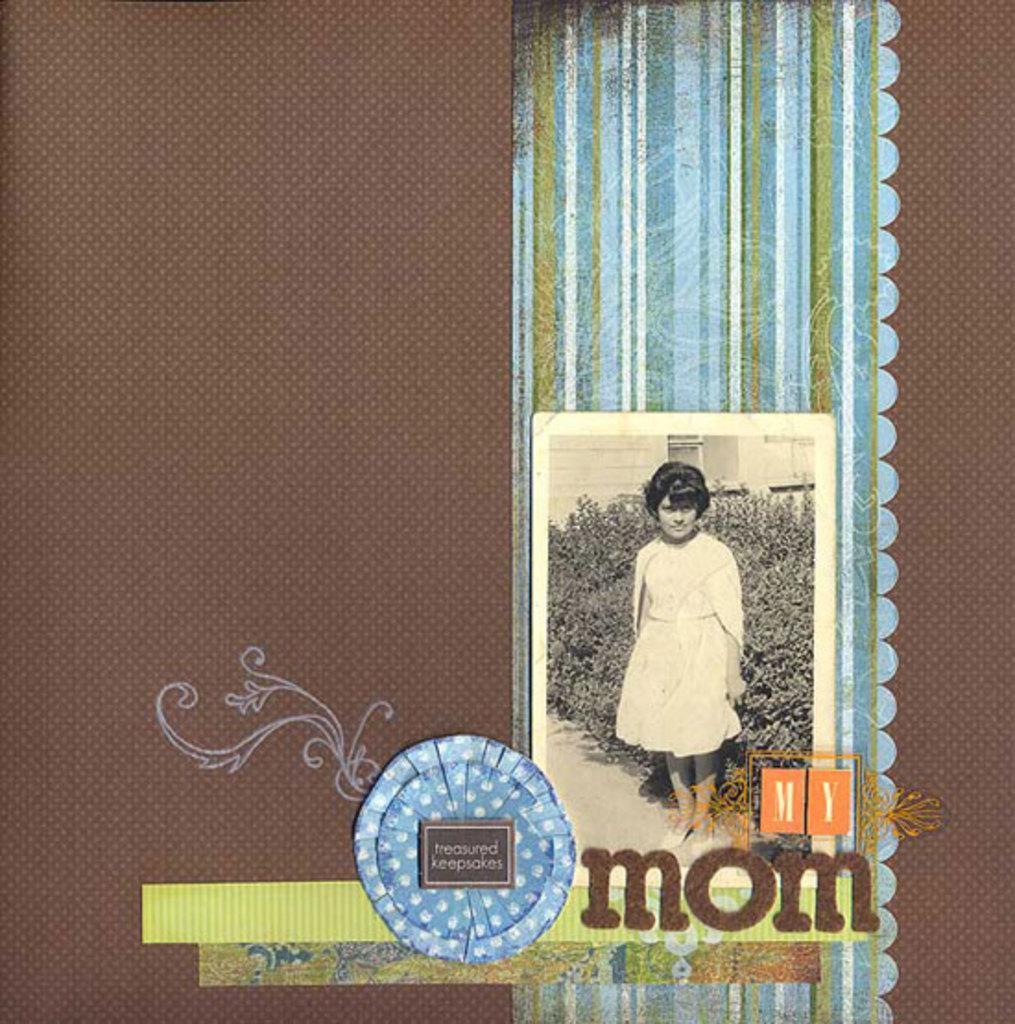Please provide a concise description of this image. In this picture I see the brown color thing on which there is a photo on which I see a girl and plants behind her and under the photo I see few words written. 